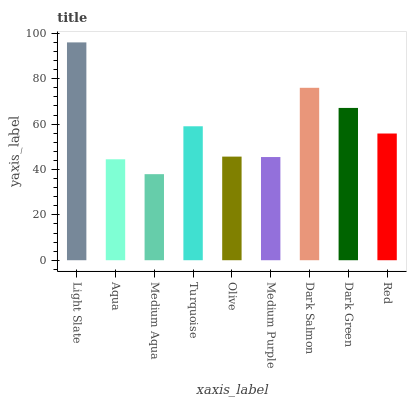Is Medium Aqua the minimum?
Answer yes or no. Yes. Is Light Slate the maximum?
Answer yes or no. Yes. Is Aqua the minimum?
Answer yes or no. No. Is Aqua the maximum?
Answer yes or no. No. Is Light Slate greater than Aqua?
Answer yes or no. Yes. Is Aqua less than Light Slate?
Answer yes or no. Yes. Is Aqua greater than Light Slate?
Answer yes or no. No. Is Light Slate less than Aqua?
Answer yes or no. No. Is Red the high median?
Answer yes or no. Yes. Is Red the low median?
Answer yes or no. Yes. Is Dark Salmon the high median?
Answer yes or no. No. Is Aqua the low median?
Answer yes or no. No. 